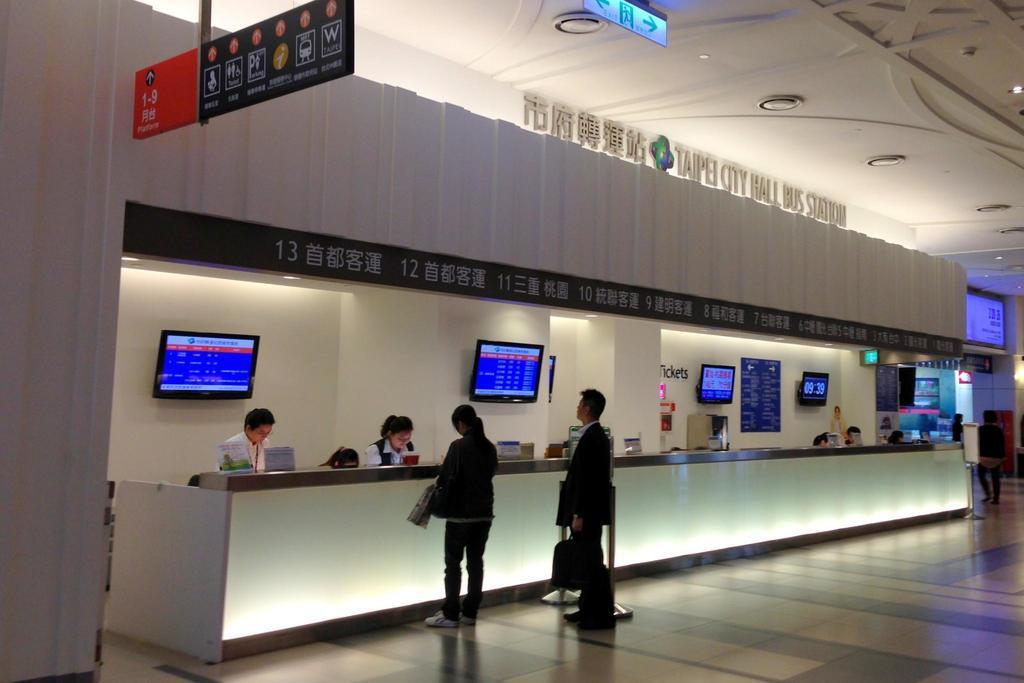How would you summarize this image in a sentence or two? In this picture we can see a man and a woman standing on the floor. There are a few boards and other objects on the desk. We can see a few Televisions and a text on the wall. There is a board on the top side. We can see a signboard and a screen in the background. 